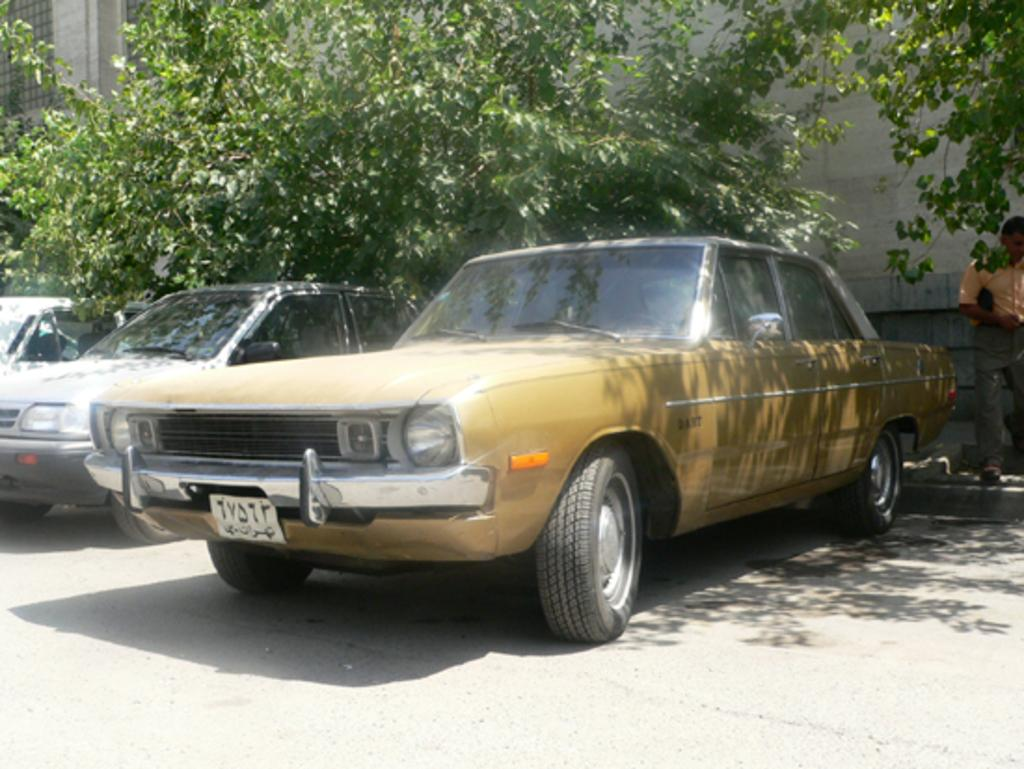What types of objects are present in the image? There are vehicles in the image. What can be seen in the background of the image? There are trees, a mesh, and a wall in the background of the image. Can you describe the person in the image? A person is standing beside a vehicle in the image. What are the characteristics of the vehicle? The vehicle has wheels and a number board. Can you see a kitten playing with an iron on the seashore in the image? No, there is no kitten, iron, or seashore present in the image. 